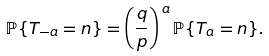Convert formula to latex. <formula><loc_0><loc_0><loc_500><loc_500>\mathbb { P } \{ T _ { - a } = n \} = \left ( \frac { q } { p } \right ) ^ { \, a } \mathbb { P } \{ T _ { a } = n \} .</formula> 